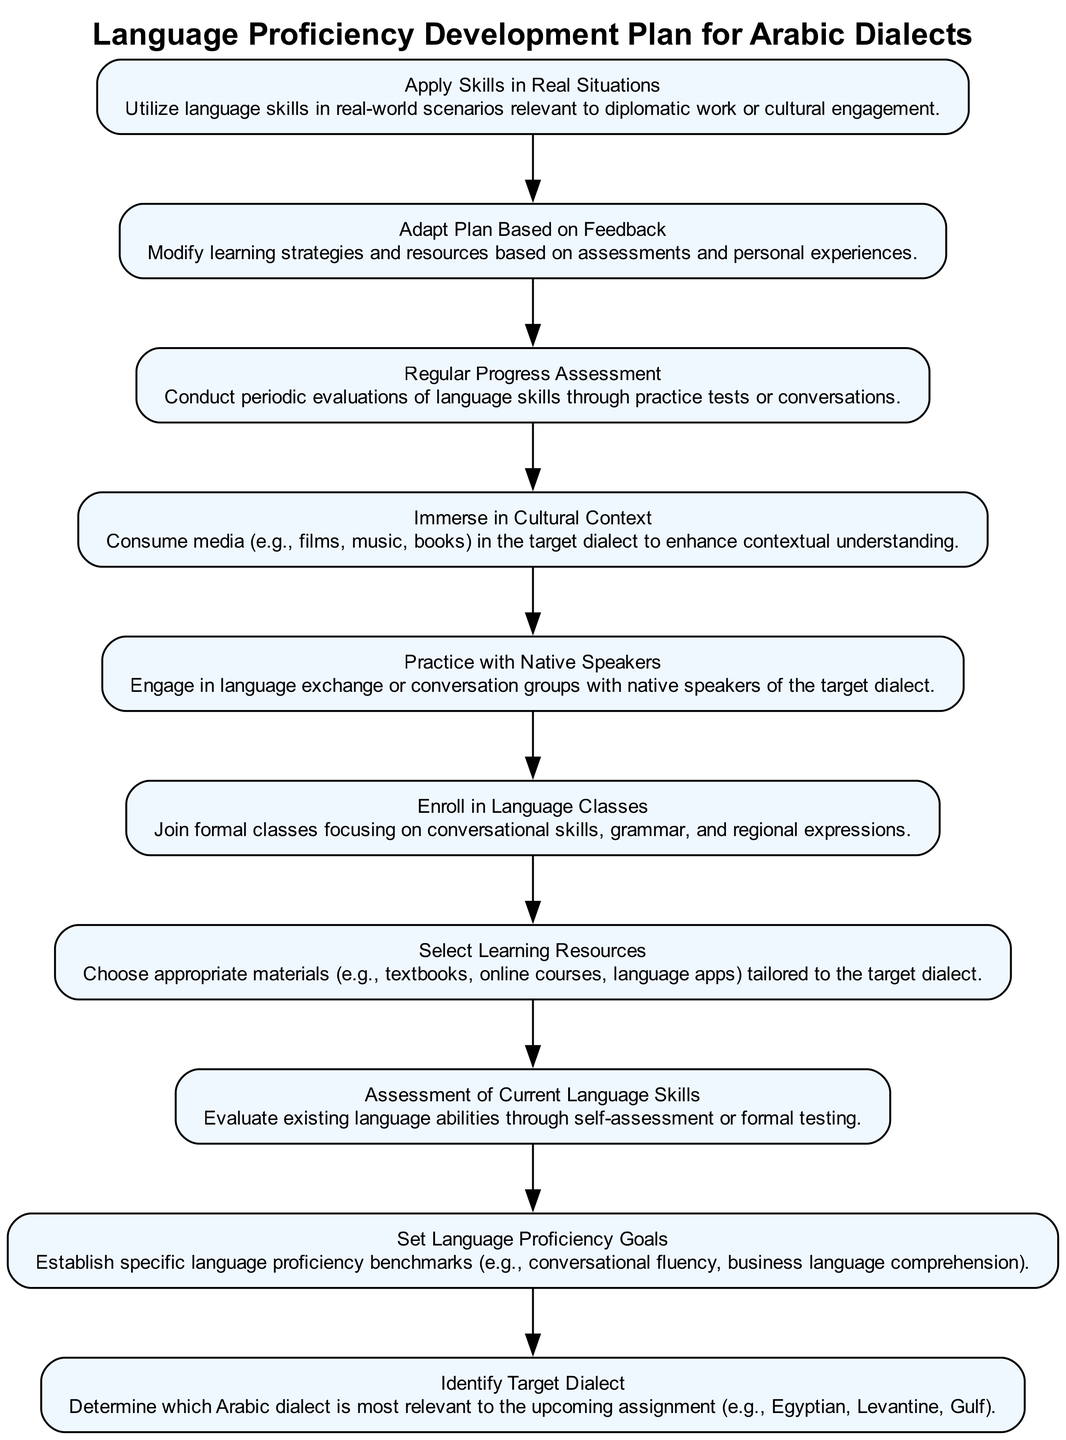What is the first step in the plan? The first node in the diagram outlines the initial stage of the language proficiency development plan, which is to "Identify Target Dialect." This node is positioned at the bottom of the diagram, indicating that it is the starting point.
Answer: Identify Target Dialect How many total nodes are in the diagram? By counting each unique step outlined in the diagram, there are ten distinct nodes present, including both actions and assessment points in the language proficiency plan.
Answer: 10 What step follows "Select Learning Resources"? Moving through the flow of the diagram, "Enroll in Language Classes" directly follows the node for selecting learning resources, indicating the next action step after resource selection.
Answer: Enroll in Language Classes What is the role of "Adapt Plan Based on Feedback"? This node represents a crucial evaluation phase where learners modify their strategies and resources based on previous assessments, indicating a reflective practice in the learning process.
Answer: Modify learning strategies Which steps are involved in the practice phase? The relevant nodes in the practice phase include "Practice with Native Speakers," "Immerse in Cultural Context," and "Regular Progress Assessment," showcasing a continuum of practical engagement and evaluation.
Answer: Practice with Native Speakers, Immerse in Cultural Context, Regular Progress Assessment How does "Set Language Proficiency Goals" relate to "Assessment of Current Language Skills"? The diagram illustrates that to establish language proficiency goals, one must first assess their current language skills. This sequential relationship highlights the dependence of goal-setting on self-evaluation.
Answer: Establish specific language proficiency benchmarks 